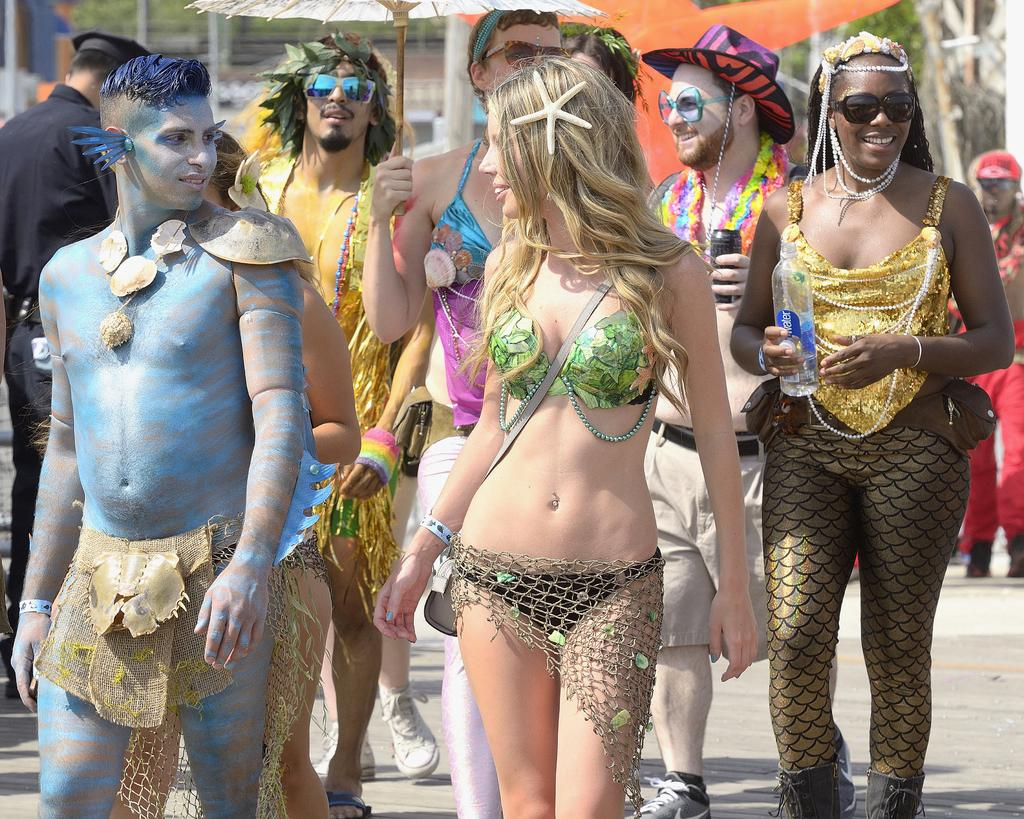What is present in the image? There are people in the image. What are the people wearing? The people are dressed up in different costumes. What are the people doing in the image? The people are walking on the road. What type of cream can be seen being spread on the bread in the image? There is no bread or cream present in the image; it features people dressed up in costumes and walking on the road. 